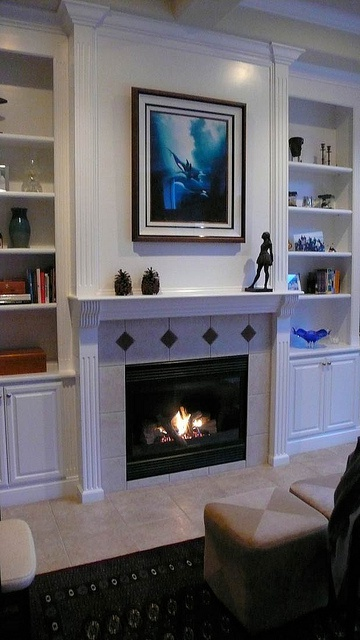Describe the objects in this image and their specific colors. I can see chair in black and gray tones, chair in black and gray tones, chair in black and gray tones, vase in black and gray tones, and vase in black, darkgray, and gray tones in this image. 